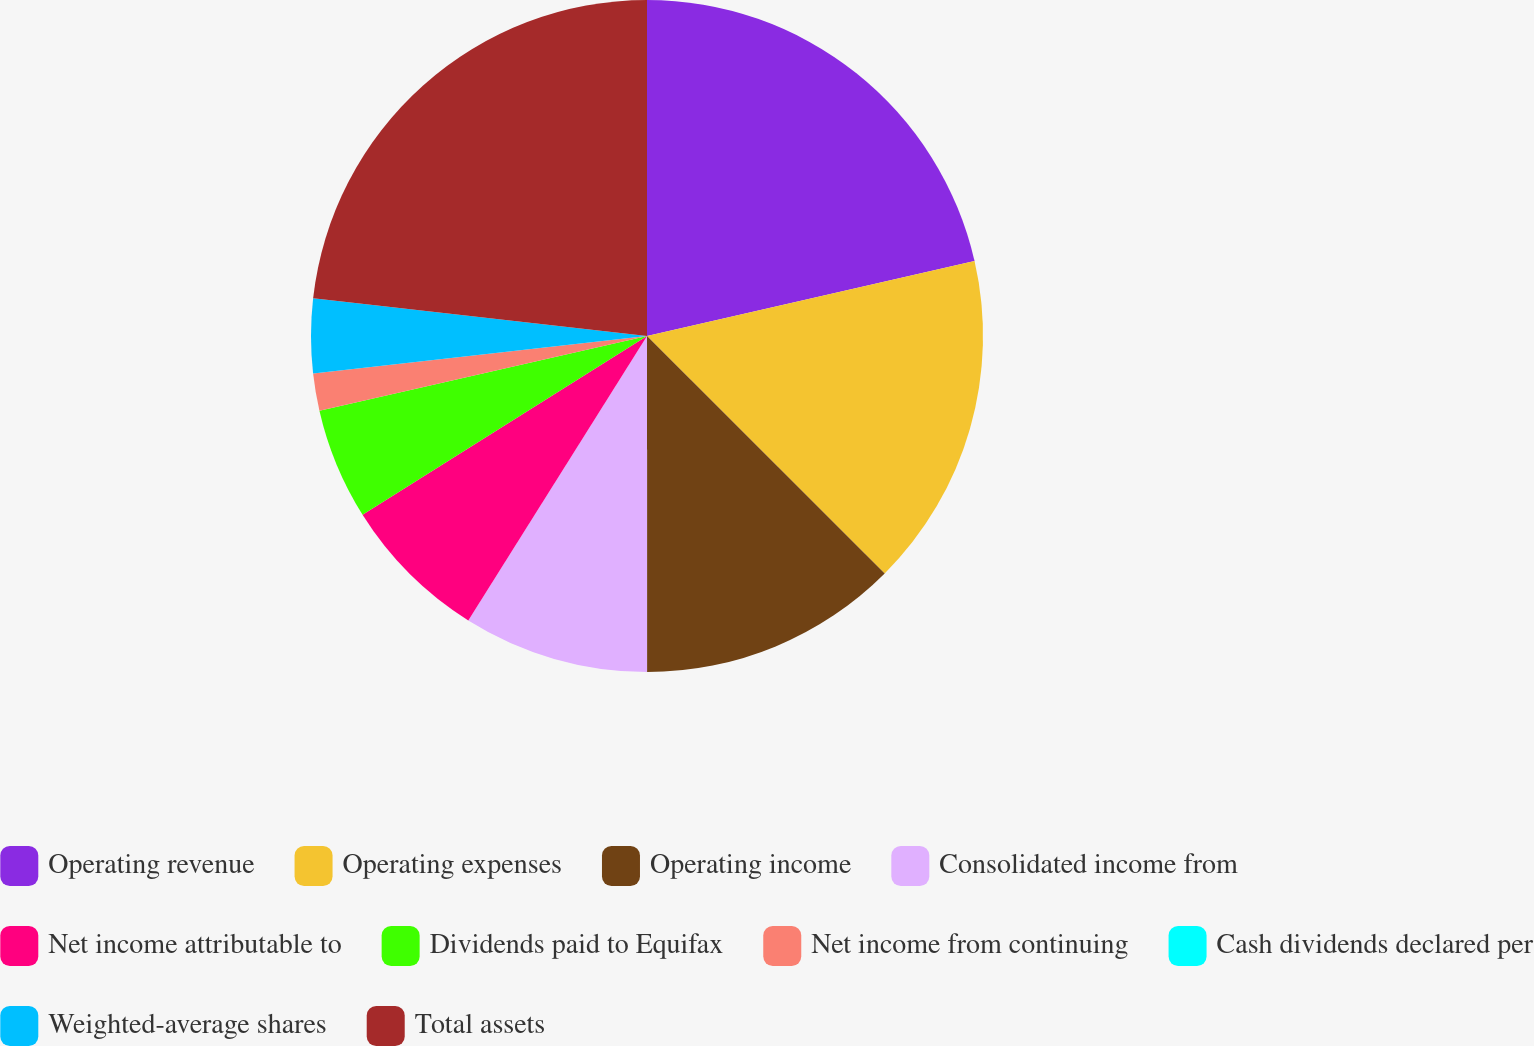Convert chart to OTSL. <chart><loc_0><loc_0><loc_500><loc_500><pie_chart><fcel>Operating revenue<fcel>Operating expenses<fcel>Operating income<fcel>Consolidated income from<fcel>Net income attributable to<fcel>Dividends paid to Equifax<fcel>Net income from continuing<fcel>Cash dividends declared per<fcel>Weighted-average shares<fcel>Total assets<nl><fcel>21.42%<fcel>16.07%<fcel>12.5%<fcel>8.93%<fcel>7.14%<fcel>5.36%<fcel>1.79%<fcel>0.0%<fcel>3.57%<fcel>23.21%<nl></chart> 